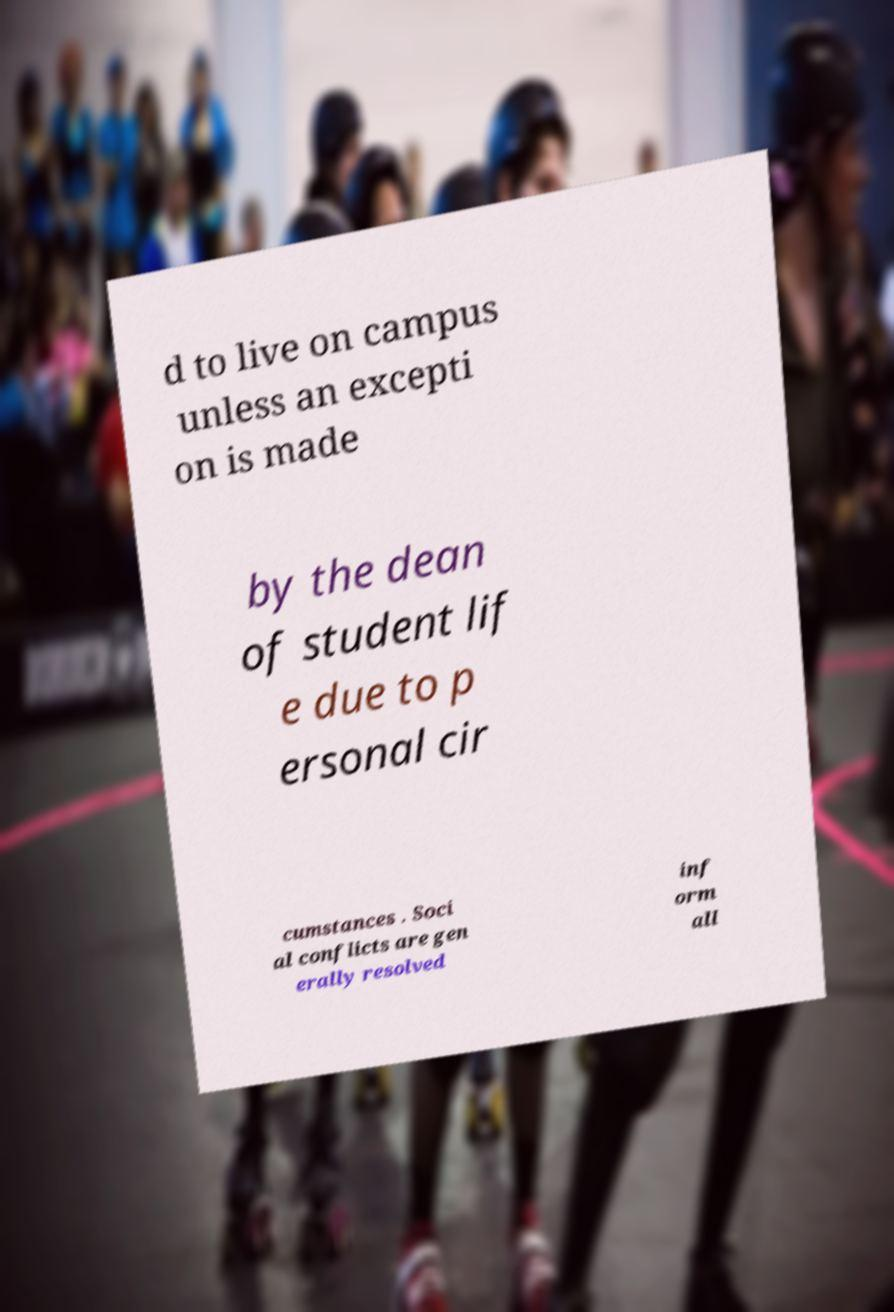I need the written content from this picture converted into text. Can you do that? d to live on campus unless an excepti on is made by the dean of student lif e due to p ersonal cir cumstances . Soci al conflicts are gen erally resolved inf orm all 